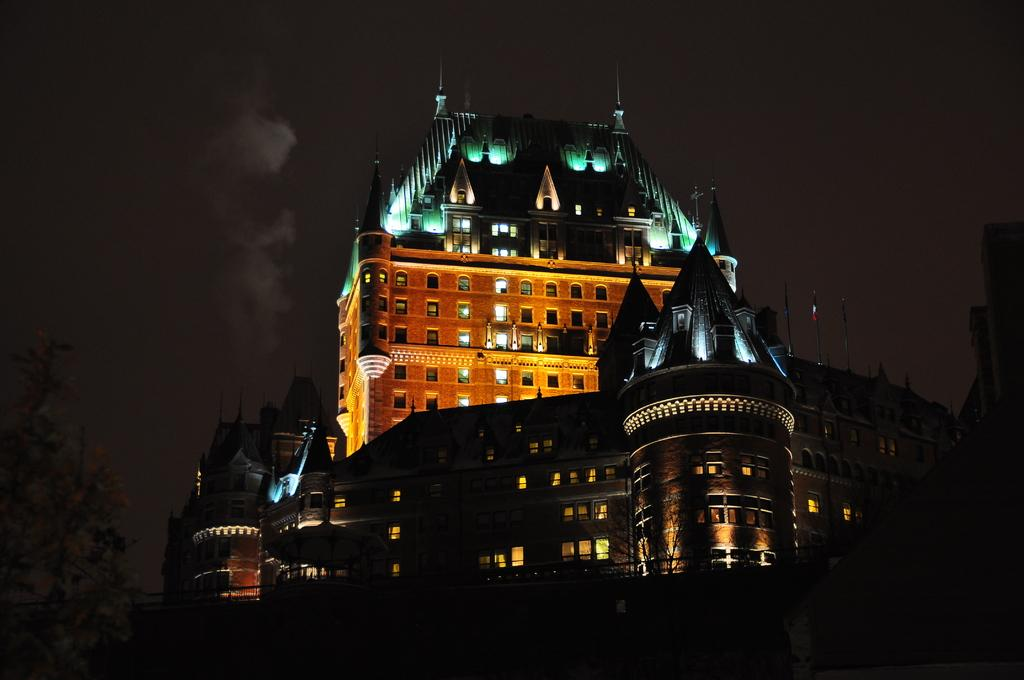What is located in the middle of the image? There is a building in the middle of the image. What can be seen in the sky in the image? There are clouds in the sky. What is visible in the background of the image? The sky is visible in the background of the image. What type of advice can be seen written on the building in the image? There is no advice visible on the building in the image; it is a structure and not a source of advice. 